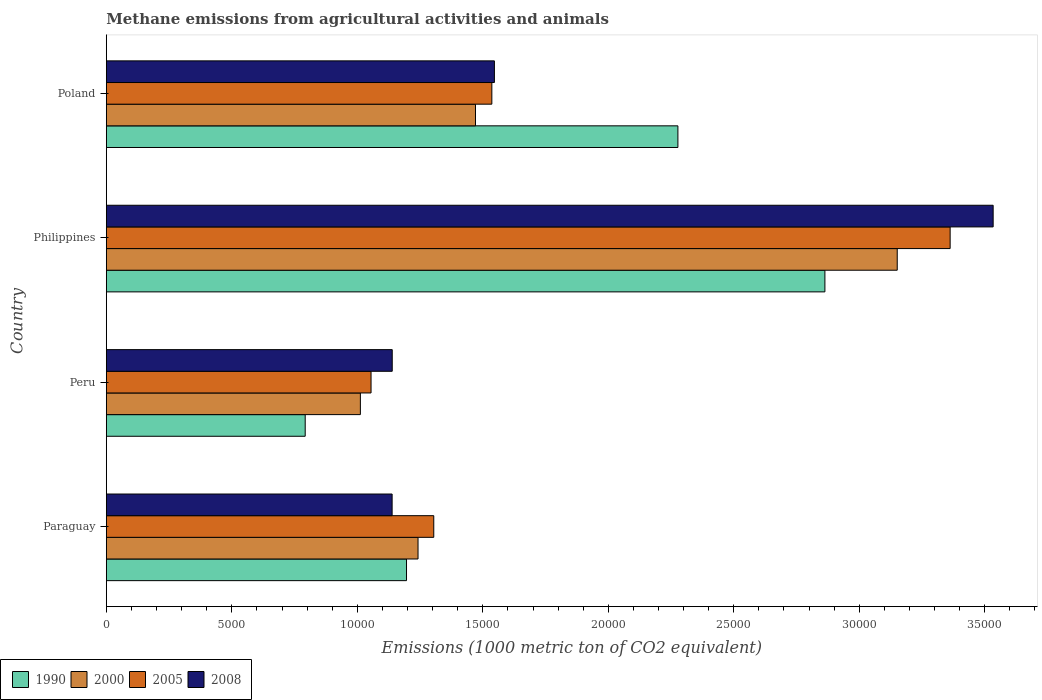How many different coloured bars are there?
Keep it short and to the point. 4. How many groups of bars are there?
Provide a succinct answer. 4. How many bars are there on the 1st tick from the bottom?
Provide a short and direct response. 4. In how many cases, is the number of bars for a given country not equal to the number of legend labels?
Your answer should be very brief. 0. What is the amount of methane emitted in 2005 in Peru?
Keep it short and to the point. 1.05e+04. Across all countries, what is the maximum amount of methane emitted in 2000?
Give a very brief answer. 3.15e+04. Across all countries, what is the minimum amount of methane emitted in 1990?
Offer a terse response. 7923.7. In which country was the amount of methane emitted in 2008 minimum?
Your response must be concise. Paraguay. What is the total amount of methane emitted in 1990 in the graph?
Keep it short and to the point. 7.13e+04. What is the difference between the amount of methane emitted in 1990 in Peru and that in Poland?
Offer a terse response. -1.48e+04. What is the difference between the amount of methane emitted in 2008 in Poland and the amount of methane emitted in 1990 in Philippines?
Your answer should be very brief. -1.32e+04. What is the average amount of methane emitted in 2005 per country?
Keep it short and to the point. 1.81e+04. What is the difference between the amount of methane emitted in 2005 and amount of methane emitted in 2000 in Philippines?
Provide a short and direct response. 2108.2. In how many countries, is the amount of methane emitted in 2000 greater than 13000 1000 metric ton?
Ensure brevity in your answer.  2. What is the ratio of the amount of methane emitted in 2000 in Peru to that in Poland?
Offer a terse response. 0.69. What is the difference between the highest and the second highest amount of methane emitted in 1990?
Your response must be concise. 5857.1. What is the difference between the highest and the lowest amount of methane emitted in 1990?
Make the answer very short. 2.07e+04. In how many countries, is the amount of methane emitted in 2000 greater than the average amount of methane emitted in 2000 taken over all countries?
Your answer should be very brief. 1. Is it the case that in every country, the sum of the amount of methane emitted in 2005 and amount of methane emitted in 2008 is greater than the sum of amount of methane emitted in 2000 and amount of methane emitted in 1990?
Your answer should be compact. No. What does the 4th bar from the top in Paraguay represents?
Your answer should be very brief. 1990. Is it the case that in every country, the sum of the amount of methane emitted in 1990 and amount of methane emitted in 2005 is greater than the amount of methane emitted in 2000?
Your answer should be very brief. Yes. How many bars are there?
Your answer should be compact. 16. Are all the bars in the graph horizontal?
Give a very brief answer. Yes. How many countries are there in the graph?
Provide a succinct answer. 4. What is the difference between two consecutive major ticks on the X-axis?
Your answer should be very brief. 5000. Does the graph contain any zero values?
Your answer should be compact. No. What is the title of the graph?
Provide a short and direct response. Methane emissions from agricultural activities and animals. What is the label or title of the X-axis?
Offer a terse response. Emissions (1000 metric ton of CO2 equivalent). What is the Emissions (1000 metric ton of CO2 equivalent) of 1990 in Paraguay?
Give a very brief answer. 1.20e+04. What is the Emissions (1000 metric ton of CO2 equivalent) of 2000 in Paraguay?
Provide a succinct answer. 1.24e+04. What is the Emissions (1000 metric ton of CO2 equivalent) in 2005 in Paraguay?
Make the answer very short. 1.30e+04. What is the Emissions (1000 metric ton of CO2 equivalent) of 2008 in Paraguay?
Your response must be concise. 1.14e+04. What is the Emissions (1000 metric ton of CO2 equivalent) of 1990 in Peru?
Provide a short and direct response. 7923.7. What is the Emissions (1000 metric ton of CO2 equivalent) in 2000 in Peru?
Your response must be concise. 1.01e+04. What is the Emissions (1000 metric ton of CO2 equivalent) in 2005 in Peru?
Give a very brief answer. 1.05e+04. What is the Emissions (1000 metric ton of CO2 equivalent) of 2008 in Peru?
Your response must be concise. 1.14e+04. What is the Emissions (1000 metric ton of CO2 equivalent) of 1990 in Philippines?
Give a very brief answer. 2.86e+04. What is the Emissions (1000 metric ton of CO2 equivalent) of 2000 in Philippines?
Your answer should be compact. 3.15e+04. What is the Emissions (1000 metric ton of CO2 equivalent) in 2005 in Philippines?
Your answer should be very brief. 3.36e+04. What is the Emissions (1000 metric ton of CO2 equivalent) in 2008 in Philippines?
Give a very brief answer. 3.53e+04. What is the Emissions (1000 metric ton of CO2 equivalent) in 1990 in Poland?
Offer a very short reply. 2.28e+04. What is the Emissions (1000 metric ton of CO2 equivalent) of 2000 in Poland?
Give a very brief answer. 1.47e+04. What is the Emissions (1000 metric ton of CO2 equivalent) in 2005 in Poland?
Your response must be concise. 1.54e+04. What is the Emissions (1000 metric ton of CO2 equivalent) of 2008 in Poland?
Give a very brief answer. 1.55e+04. Across all countries, what is the maximum Emissions (1000 metric ton of CO2 equivalent) in 1990?
Your answer should be very brief. 2.86e+04. Across all countries, what is the maximum Emissions (1000 metric ton of CO2 equivalent) of 2000?
Offer a terse response. 3.15e+04. Across all countries, what is the maximum Emissions (1000 metric ton of CO2 equivalent) in 2005?
Make the answer very short. 3.36e+04. Across all countries, what is the maximum Emissions (1000 metric ton of CO2 equivalent) in 2008?
Keep it short and to the point. 3.53e+04. Across all countries, what is the minimum Emissions (1000 metric ton of CO2 equivalent) of 1990?
Your answer should be very brief. 7923.7. Across all countries, what is the minimum Emissions (1000 metric ton of CO2 equivalent) in 2000?
Your answer should be compact. 1.01e+04. Across all countries, what is the minimum Emissions (1000 metric ton of CO2 equivalent) in 2005?
Provide a succinct answer. 1.05e+04. Across all countries, what is the minimum Emissions (1000 metric ton of CO2 equivalent) of 2008?
Offer a very short reply. 1.14e+04. What is the total Emissions (1000 metric ton of CO2 equivalent) in 1990 in the graph?
Ensure brevity in your answer.  7.13e+04. What is the total Emissions (1000 metric ton of CO2 equivalent) of 2000 in the graph?
Keep it short and to the point. 6.88e+04. What is the total Emissions (1000 metric ton of CO2 equivalent) in 2005 in the graph?
Provide a short and direct response. 7.26e+04. What is the total Emissions (1000 metric ton of CO2 equivalent) of 2008 in the graph?
Keep it short and to the point. 7.36e+04. What is the difference between the Emissions (1000 metric ton of CO2 equivalent) in 1990 in Paraguay and that in Peru?
Provide a short and direct response. 4036.7. What is the difference between the Emissions (1000 metric ton of CO2 equivalent) in 2000 in Paraguay and that in Peru?
Provide a short and direct response. 2297.3. What is the difference between the Emissions (1000 metric ton of CO2 equivalent) in 2005 in Paraguay and that in Peru?
Your response must be concise. 2498.9. What is the difference between the Emissions (1000 metric ton of CO2 equivalent) in 2008 in Paraguay and that in Peru?
Make the answer very short. -4.4. What is the difference between the Emissions (1000 metric ton of CO2 equivalent) in 1990 in Paraguay and that in Philippines?
Keep it short and to the point. -1.67e+04. What is the difference between the Emissions (1000 metric ton of CO2 equivalent) in 2000 in Paraguay and that in Philippines?
Offer a terse response. -1.91e+04. What is the difference between the Emissions (1000 metric ton of CO2 equivalent) in 2005 in Paraguay and that in Philippines?
Ensure brevity in your answer.  -2.06e+04. What is the difference between the Emissions (1000 metric ton of CO2 equivalent) of 2008 in Paraguay and that in Philippines?
Make the answer very short. -2.39e+04. What is the difference between the Emissions (1000 metric ton of CO2 equivalent) in 1990 in Paraguay and that in Poland?
Provide a short and direct response. -1.08e+04. What is the difference between the Emissions (1000 metric ton of CO2 equivalent) in 2000 in Paraguay and that in Poland?
Your response must be concise. -2289.3. What is the difference between the Emissions (1000 metric ton of CO2 equivalent) of 2005 in Paraguay and that in Poland?
Make the answer very short. -2313.8. What is the difference between the Emissions (1000 metric ton of CO2 equivalent) of 2008 in Paraguay and that in Poland?
Your answer should be compact. -4075.8. What is the difference between the Emissions (1000 metric ton of CO2 equivalent) in 1990 in Peru and that in Philippines?
Provide a short and direct response. -2.07e+04. What is the difference between the Emissions (1000 metric ton of CO2 equivalent) of 2000 in Peru and that in Philippines?
Offer a very short reply. -2.14e+04. What is the difference between the Emissions (1000 metric ton of CO2 equivalent) of 2005 in Peru and that in Philippines?
Your answer should be very brief. -2.31e+04. What is the difference between the Emissions (1000 metric ton of CO2 equivalent) of 2008 in Peru and that in Philippines?
Your answer should be compact. -2.39e+04. What is the difference between the Emissions (1000 metric ton of CO2 equivalent) in 1990 in Peru and that in Poland?
Offer a terse response. -1.48e+04. What is the difference between the Emissions (1000 metric ton of CO2 equivalent) in 2000 in Peru and that in Poland?
Your answer should be very brief. -4586.6. What is the difference between the Emissions (1000 metric ton of CO2 equivalent) of 2005 in Peru and that in Poland?
Provide a short and direct response. -4812.7. What is the difference between the Emissions (1000 metric ton of CO2 equivalent) in 2008 in Peru and that in Poland?
Ensure brevity in your answer.  -4071.4. What is the difference between the Emissions (1000 metric ton of CO2 equivalent) in 1990 in Philippines and that in Poland?
Give a very brief answer. 5857.1. What is the difference between the Emissions (1000 metric ton of CO2 equivalent) of 2000 in Philippines and that in Poland?
Your answer should be compact. 1.68e+04. What is the difference between the Emissions (1000 metric ton of CO2 equivalent) in 2005 in Philippines and that in Poland?
Provide a succinct answer. 1.83e+04. What is the difference between the Emissions (1000 metric ton of CO2 equivalent) of 2008 in Philippines and that in Poland?
Provide a short and direct response. 1.99e+04. What is the difference between the Emissions (1000 metric ton of CO2 equivalent) of 1990 in Paraguay and the Emissions (1000 metric ton of CO2 equivalent) of 2000 in Peru?
Your answer should be very brief. 1838.5. What is the difference between the Emissions (1000 metric ton of CO2 equivalent) in 1990 in Paraguay and the Emissions (1000 metric ton of CO2 equivalent) in 2005 in Peru?
Your answer should be very brief. 1413.3. What is the difference between the Emissions (1000 metric ton of CO2 equivalent) of 1990 in Paraguay and the Emissions (1000 metric ton of CO2 equivalent) of 2008 in Peru?
Provide a succinct answer. 569.4. What is the difference between the Emissions (1000 metric ton of CO2 equivalent) in 2000 in Paraguay and the Emissions (1000 metric ton of CO2 equivalent) in 2005 in Peru?
Make the answer very short. 1872.1. What is the difference between the Emissions (1000 metric ton of CO2 equivalent) of 2000 in Paraguay and the Emissions (1000 metric ton of CO2 equivalent) of 2008 in Peru?
Offer a terse response. 1028.2. What is the difference between the Emissions (1000 metric ton of CO2 equivalent) of 2005 in Paraguay and the Emissions (1000 metric ton of CO2 equivalent) of 2008 in Peru?
Your answer should be very brief. 1655. What is the difference between the Emissions (1000 metric ton of CO2 equivalent) of 1990 in Paraguay and the Emissions (1000 metric ton of CO2 equivalent) of 2000 in Philippines?
Provide a succinct answer. -1.96e+04. What is the difference between the Emissions (1000 metric ton of CO2 equivalent) in 1990 in Paraguay and the Emissions (1000 metric ton of CO2 equivalent) in 2005 in Philippines?
Make the answer very short. -2.17e+04. What is the difference between the Emissions (1000 metric ton of CO2 equivalent) of 1990 in Paraguay and the Emissions (1000 metric ton of CO2 equivalent) of 2008 in Philippines?
Make the answer very short. -2.34e+04. What is the difference between the Emissions (1000 metric ton of CO2 equivalent) in 2000 in Paraguay and the Emissions (1000 metric ton of CO2 equivalent) in 2005 in Philippines?
Provide a succinct answer. -2.12e+04. What is the difference between the Emissions (1000 metric ton of CO2 equivalent) in 2000 in Paraguay and the Emissions (1000 metric ton of CO2 equivalent) in 2008 in Philippines?
Your response must be concise. -2.29e+04. What is the difference between the Emissions (1000 metric ton of CO2 equivalent) of 2005 in Paraguay and the Emissions (1000 metric ton of CO2 equivalent) of 2008 in Philippines?
Provide a succinct answer. -2.23e+04. What is the difference between the Emissions (1000 metric ton of CO2 equivalent) of 1990 in Paraguay and the Emissions (1000 metric ton of CO2 equivalent) of 2000 in Poland?
Offer a very short reply. -2748.1. What is the difference between the Emissions (1000 metric ton of CO2 equivalent) of 1990 in Paraguay and the Emissions (1000 metric ton of CO2 equivalent) of 2005 in Poland?
Provide a succinct answer. -3399.4. What is the difference between the Emissions (1000 metric ton of CO2 equivalent) of 1990 in Paraguay and the Emissions (1000 metric ton of CO2 equivalent) of 2008 in Poland?
Your answer should be very brief. -3502. What is the difference between the Emissions (1000 metric ton of CO2 equivalent) in 2000 in Paraguay and the Emissions (1000 metric ton of CO2 equivalent) in 2005 in Poland?
Your response must be concise. -2940.6. What is the difference between the Emissions (1000 metric ton of CO2 equivalent) in 2000 in Paraguay and the Emissions (1000 metric ton of CO2 equivalent) in 2008 in Poland?
Ensure brevity in your answer.  -3043.2. What is the difference between the Emissions (1000 metric ton of CO2 equivalent) in 2005 in Paraguay and the Emissions (1000 metric ton of CO2 equivalent) in 2008 in Poland?
Your answer should be compact. -2416.4. What is the difference between the Emissions (1000 metric ton of CO2 equivalent) in 1990 in Peru and the Emissions (1000 metric ton of CO2 equivalent) in 2000 in Philippines?
Provide a succinct answer. -2.36e+04. What is the difference between the Emissions (1000 metric ton of CO2 equivalent) of 1990 in Peru and the Emissions (1000 metric ton of CO2 equivalent) of 2005 in Philippines?
Your answer should be compact. -2.57e+04. What is the difference between the Emissions (1000 metric ton of CO2 equivalent) in 1990 in Peru and the Emissions (1000 metric ton of CO2 equivalent) in 2008 in Philippines?
Your answer should be compact. -2.74e+04. What is the difference between the Emissions (1000 metric ton of CO2 equivalent) in 2000 in Peru and the Emissions (1000 metric ton of CO2 equivalent) in 2005 in Philippines?
Your answer should be very brief. -2.35e+04. What is the difference between the Emissions (1000 metric ton of CO2 equivalent) of 2000 in Peru and the Emissions (1000 metric ton of CO2 equivalent) of 2008 in Philippines?
Provide a succinct answer. -2.52e+04. What is the difference between the Emissions (1000 metric ton of CO2 equivalent) in 2005 in Peru and the Emissions (1000 metric ton of CO2 equivalent) in 2008 in Philippines?
Keep it short and to the point. -2.48e+04. What is the difference between the Emissions (1000 metric ton of CO2 equivalent) of 1990 in Peru and the Emissions (1000 metric ton of CO2 equivalent) of 2000 in Poland?
Make the answer very short. -6784.8. What is the difference between the Emissions (1000 metric ton of CO2 equivalent) in 1990 in Peru and the Emissions (1000 metric ton of CO2 equivalent) in 2005 in Poland?
Make the answer very short. -7436.1. What is the difference between the Emissions (1000 metric ton of CO2 equivalent) of 1990 in Peru and the Emissions (1000 metric ton of CO2 equivalent) of 2008 in Poland?
Offer a terse response. -7538.7. What is the difference between the Emissions (1000 metric ton of CO2 equivalent) in 2000 in Peru and the Emissions (1000 metric ton of CO2 equivalent) in 2005 in Poland?
Keep it short and to the point. -5237.9. What is the difference between the Emissions (1000 metric ton of CO2 equivalent) in 2000 in Peru and the Emissions (1000 metric ton of CO2 equivalent) in 2008 in Poland?
Give a very brief answer. -5340.5. What is the difference between the Emissions (1000 metric ton of CO2 equivalent) of 2005 in Peru and the Emissions (1000 metric ton of CO2 equivalent) of 2008 in Poland?
Make the answer very short. -4915.3. What is the difference between the Emissions (1000 metric ton of CO2 equivalent) in 1990 in Philippines and the Emissions (1000 metric ton of CO2 equivalent) in 2000 in Poland?
Make the answer very short. 1.39e+04. What is the difference between the Emissions (1000 metric ton of CO2 equivalent) of 1990 in Philippines and the Emissions (1000 metric ton of CO2 equivalent) of 2005 in Poland?
Keep it short and to the point. 1.33e+04. What is the difference between the Emissions (1000 metric ton of CO2 equivalent) of 1990 in Philippines and the Emissions (1000 metric ton of CO2 equivalent) of 2008 in Poland?
Provide a succinct answer. 1.32e+04. What is the difference between the Emissions (1000 metric ton of CO2 equivalent) of 2000 in Philippines and the Emissions (1000 metric ton of CO2 equivalent) of 2005 in Poland?
Provide a succinct answer. 1.62e+04. What is the difference between the Emissions (1000 metric ton of CO2 equivalent) in 2000 in Philippines and the Emissions (1000 metric ton of CO2 equivalent) in 2008 in Poland?
Ensure brevity in your answer.  1.60e+04. What is the difference between the Emissions (1000 metric ton of CO2 equivalent) of 2005 in Philippines and the Emissions (1000 metric ton of CO2 equivalent) of 2008 in Poland?
Provide a succinct answer. 1.82e+04. What is the average Emissions (1000 metric ton of CO2 equivalent) of 1990 per country?
Keep it short and to the point. 1.78e+04. What is the average Emissions (1000 metric ton of CO2 equivalent) of 2000 per country?
Provide a succinct answer. 1.72e+04. What is the average Emissions (1000 metric ton of CO2 equivalent) of 2005 per country?
Give a very brief answer. 1.81e+04. What is the average Emissions (1000 metric ton of CO2 equivalent) in 2008 per country?
Make the answer very short. 1.84e+04. What is the difference between the Emissions (1000 metric ton of CO2 equivalent) of 1990 and Emissions (1000 metric ton of CO2 equivalent) of 2000 in Paraguay?
Offer a terse response. -458.8. What is the difference between the Emissions (1000 metric ton of CO2 equivalent) of 1990 and Emissions (1000 metric ton of CO2 equivalent) of 2005 in Paraguay?
Provide a succinct answer. -1085.6. What is the difference between the Emissions (1000 metric ton of CO2 equivalent) of 1990 and Emissions (1000 metric ton of CO2 equivalent) of 2008 in Paraguay?
Your answer should be compact. 573.8. What is the difference between the Emissions (1000 metric ton of CO2 equivalent) in 2000 and Emissions (1000 metric ton of CO2 equivalent) in 2005 in Paraguay?
Keep it short and to the point. -626.8. What is the difference between the Emissions (1000 metric ton of CO2 equivalent) of 2000 and Emissions (1000 metric ton of CO2 equivalent) of 2008 in Paraguay?
Ensure brevity in your answer.  1032.6. What is the difference between the Emissions (1000 metric ton of CO2 equivalent) of 2005 and Emissions (1000 metric ton of CO2 equivalent) of 2008 in Paraguay?
Your answer should be very brief. 1659.4. What is the difference between the Emissions (1000 metric ton of CO2 equivalent) in 1990 and Emissions (1000 metric ton of CO2 equivalent) in 2000 in Peru?
Your response must be concise. -2198.2. What is the difference between the Emissions (1000 metric ton of CO2 equivalent) in 1990 and Emissions (1000 metric ton of CO2 equivalent) in 2005 in Peru?
Offer a terse response. -2623.4. What is the difference between the Emissions (1000 metric ton of CO2 equivalent) in 1990 and Emissions (1000 metric ton of CO2 equivalent) in 2008 in Peru?
Your response must be concise. -3467.3. What is the difference between the Emissions (1000 metric ton of CO2 equivalent) of 2000 and Emissions (1000 metric ton of CO2 equivalent) of 2005 in Peru?
Your answer should be compact. -425.2. What is the difference between the Emissions (1000 metric ton of CO2 equivalent) of 2000 and Emissions (1000 metric ton of CO2 equivalent) of 2008 in Peru?
Offer a very short reply. -1269.1. What is the difference between the Emissions (1000 metric ton of CO2 equivalent) of 2005 and Emissions (1000 metric ton of CO2 equivalent) of 2008 in Peru?
Offer a terse response. -843.9. What is the difference between the Emissions (1000 metric ton of CO2 equivalent) in 1990 and Emissions (1000 metric ton of CO2 equivalent) in 2000 in Philippines?
Offer a very short reply. -2881.3. What is the difference between the Emissions (1000 metric ton of CO2 equivalent) of 1990 and Emissions (1000 metric ton of CO2 equivalent) of 2005 in Philippines?
Your response must be concise. -4989.5. What is the difference between the Emissions (1000 metric ton of CO2 equivalent) in 1990 and Emissions (1000 metric ton of CO2 equivalent) in 2008 in Philippines?
Your response must be concise. -6703.2. What is the difference between the Emissions (1000 metric ton of CO2 equivalent) of 2000 and Emissions (1000 metric ton of CO2 equivalent) of 2005 in Philippines?
Provide a succinct answer. -2108.2. What is the difference between the Emissions (1000 metric ton of CO2 equivalent) in 2000 and Emissions (1000 metric ton of CO2 equivalent) in 2008 in Philippines?
Make the answer very short. -3821.9. What is the difference between the Emissions (1000 metric ton of CO2 equivalent) of 2005 and Emissions (1000 metric ton of CO2 equivalent) of 2008 in Philippines?
Offer a terse response. -1713.7. What is the difference between the Emissions (1000 metric ton of CO2 equivalent) in 1990 and Emissions (1000 metric ton of CO2 equivalent) in 2000 in Poland?
Make the answer very short. 8065. What is the difference between the Emissions (1000 metric ton of CO2 equivalent) in 1990 and Emissions (1000 metric ton of CO2 equivalent) in 2005 in Poland?
Give a very brief answer. 7413.7. What is the difference between the Emissions (1000 metric ton of CO2 equivalent) of 1990 and Emissions (1000 metric ton of CO2 equivalent) of 2008 in Poland?
Your answer should be compact. 7311.1. What is the difference between the Emissions (1000 metric ton of CO2 equivalent) in 2000 and Emissions (1000 metric ton of CO2 equivalent) in 2005 in Poland?
Your answer should be very brief. -651.3. What is the difference between the Emissions (1000 metric ton of CO2 equivalent) in 2000 and Emissions (1000 metric ton of CO2 equivalent) in 2008 in Poland?
Keep it short and to the point. -753.9. What is the difference between the Emissions (1000 metric ton of CO2 equivalent) in 2005 and Emissions (1000 metric ton of CO2 equivalent) in 2008 in Poland?
Give a very brief answer. -102.6. What is the ratio of the Emissions (1000 metric ton of CO2 equivalent) of 1990 in Paraguay to that in Peru?
Offer a terse response. 1.51. What is the ratio of the Emissions (1000 metric ton of CO2 equivalent) in 2000 in Paraguay to that in Peru?
Make the answer very short. 1.23. What is the ratio of the Emissions (1000 metric ton of CO2 equivalent) in 2005 in Paraguay to that in Peru?
Your response must be concise. 1.24. What is the ratio of the Emissions (1000 metric ton of CO2 equivalent) in 1990 in Paraguay to that in Philippines?
Your response must be concise. 0.42. What is the ratio of the Emissions (1000 metric ton of CO2 equivalent) of 2000 in Paraguay to that in Philippines?
Your answer should be compact. 0.39. What is the ratio of the Emissions (1000 metric ton of CO2 equivalent) in 2005 in Paraguay to that in Philippines?
Give a very brief answer. 0.39. What is the ratio of the Emissions (1000 metric ton of CO2 equivalent) in 2008 in Paraguay to that in Philippines?
Your answer should be compact. 0.32. What is the ratio of the Emissions (1000 metric ton of CO2 equivalent) of 1990 in Paraguay to that in Poland?
Your answer should be very brief. 0.53. What is the ratio of the Emissions (1000 metric ton of CO2 equivalent) in 2000 in Paraguay to that in Poland?
Make the answer very short. 0.84. What is the ratio of the Emissions (1000 metric ton of CO2 equivalent) of 2005 in Paraguay to that in Poland?
Offer a terse response. 0.85. What is the ratio of the Emissions (1000 metric ton of CO2 equivalent) in 2008 in Paraguay to that in Poland?
Your answer should be very brief. 0.74. What is the ratio of the Emissions (1000 metric ton of CO2 equivalent) in 1990 in Peru to that in Philippines?
Your response must be concise. 0.28. What is the ratio of the Emissions (1000 metric ton of CO2 equivalent) of 2000 in Peru to that in Philippines?
Your answer should be compact. 0.32. What is the ratio of the Emissions (1000 metric ton of CO2 equivalent) of 2005 in Peru to that in Philippines?
Your answer should be compact. 0.31. What is the ratio of the Emissions (1000 metric ton of CO2 equivalent) of 2008 in Peru to that in Philippines?
Your answer should be very brief. 0.32. What is the ratio of the Emissions (1000 metric ton of CO2 equivalent) in 1990 in Peru to that in Poland?
Keep it short and to the point. 0.35. What is the ratio of the Emissions (1000 metric ton of CO2 equivalent) in 2000 in Peru to that in Poland?
Give a very brief answer. 0.69. What is the ratio of the Emissions (1000 metric ton of CO2 equivalent) of 2005 in Peru to that in Poland?
Ensure brevity in your answer.  0.69. What is the ratio of the Emissions (1000 metric ton of CO2 equivalent) of 2008 in Peru to that in Poland?
Your response must be concise. 0.74. What is the ratio of the Emissions (1000 metric ton of CO2 equivalent) of 1990 in Philippines to that in Poland?
Provide a short and direct response. 1.26. What is the ratio of the Emissions (1000 metric ton of CO2 equivalent) of 2000 in Philippines to that in Poland?
Make the answer very short. 2.14. What is the ratio of the Emissions (1000 metric ton of CO2 equivalent) in 2005 in Philippines to that in Poland?
Provide a short and direct response. 2.19. What is the ratio of the Emissions (1000 metric ton of CO2 equivalent) of 2008 in Philippines to that in Poland?
Provide a short and direct response. 2.29. What is the difference between the highest and the second highest Emissions (1000 metric ton of CO2 equivalent) in 1990?
Offer a very short reply. 5857.1. What is the difference between the highest and the second highest Emissions (1000 metric ton of CO2 equivalent) in 2000?
Provide a succinct answer. 1.68e+04. What is the difference between the highest and the second highest Emissions (1000 metric ton of CO2 equivalent) of 2005?
Offer a terse response. 1.83e+04. What is the difference between the highest and the second highest Emissions (1000 metric ton of CO2 equivalent) of 2008?
Provide a short and direct response. 1.99e+04. What is the difference between the highest and the lowest Emissions (1000 metric ton of CO2 equivalent) of 1990?
Offer a very short reply. 2.07e+04. What is the difference between the highest and the lowest Emissions (1000 metric ton of CO2 equivalent) of 2000?
Your answer should be compact. 2.14e+04. What is the difference between the highest and the lowest Emissions (1000 metric ton of CO2 equivalent) of 2005?
Make the answer very short. 2.31e+04. What is the difference between the highest and the lowest Emissions (1000 metric ton of CO2 equivalent) in 2008?
Offer a terse response. 2.39e+04. 